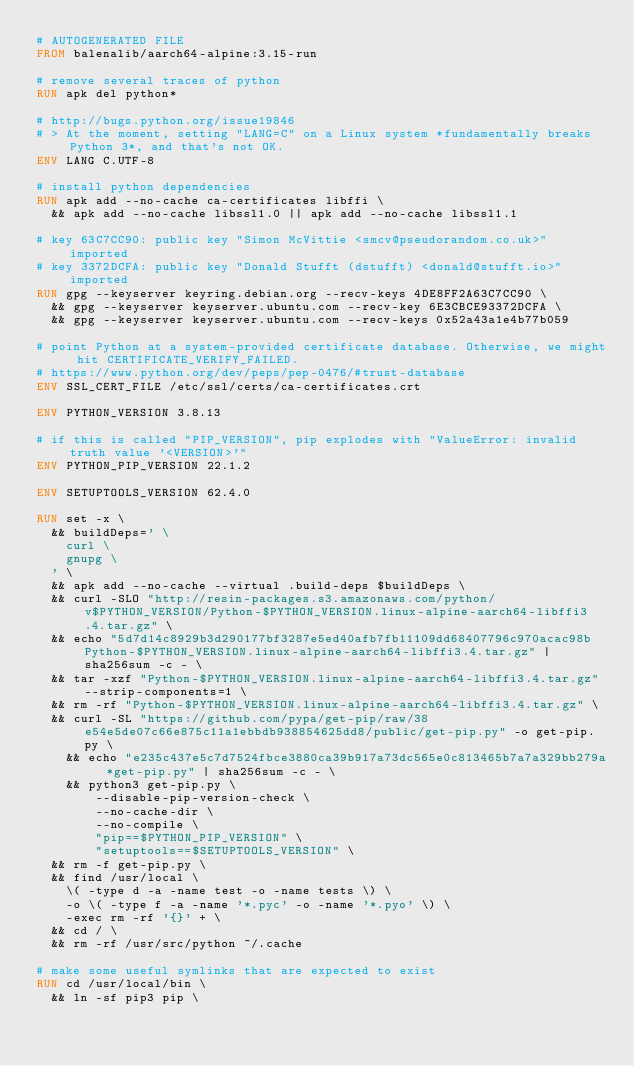<code> <loc_0><loc_0><loc_500><loc_500><_Dockerfile_># AUTOGENERATED FILE
FROM balenalib/aarch64-alpine:3.15-run

# remove several traces of python
RUN apk del python*

# http://bugs.python.org/issue19846
# > At the moment, setting "LANG=C" on a Linux system *fundamentally breaks Python 3*, and that's not OK.
ENV LANG C.UTF-8

# install python dependencies
RUN apk add --no-cache ca-certificates libffi \
	&& apk add --no-cache libssl1.0 || apk add --no-cache libssl1.1

# key 63C7CC90: public key "Simon McVittie <smcv@pseudorandom.co.uk>" imported
# key 3372DCFA: public key "Donald Stufft (dstufft) <donald@stufft.io>" imported
RUN gpg --keyserver keyring.debian.org --recv-keys 4DE8FF2A63C7CC90 \
	&& gpg --keyserver keyserver.ubuntu.com --recv-key 6E3CBCE93372DCFA \
	&& gpg --keyserver keyserver.ubuntu.com --recv-keys 0x52a43a1e4b77b059

# point Python at a system-provided certificate database. Otherwise, we might hit CERTIFICATE_VERIFY_FAILED.
# https://www.python.org/dev/peps/pep-0476/#trust-database
ENV SSL_CERT_FILE /etc/ssl/certs/ca-certificates.crt

ENV PYTHON_VERSION 3.8.13

# if this is called "PIP_VERSION", pip explodes with "ValueError: invalid truth value '<VERSION>'"
ENV PYTHON_PIP_VERSION 22.1.2

ENV SETUPTOOLS_VERSION 62.4.0

RUN set -x \
	&& buildDeps=' \
		curl \
		gnupg \
	' \
	&& apk add --no-cache --virtual .build-deps $buildDeps \
	&& curl -SLO "http://resin-packages.s3.amazonaws.com/python/v$PYTHON_VERSION/Python-$PYTHON_VERSION.linux-alpine-aarch64-libffi3.4.tar.gz" \
	&& echo "5d7d14c8929b3d290177bf3287e5ed40afb7fb11109dd68407796c970acac98b  Python-$PYTHON_VERSION.linux-alpine-aarch64-libffi3.4.tar.gz" | sha256sum -c - \
	&& tar -xzf "Python-$PYTHON_VERSION.linux-alpine-aarch64-libffi3.4.tar.gz" --strip-components=1 \
	&& rm -rf "Python-$PYTHON_VERSION.linux-alpine-aarch64-libffi3.4.tar.gz" \
	&& curl -SL "https://github.com/pypa/get-pip/raw/38e54e5de07c66e875c11a1ebbdb938854625dd8/public/get-pip.py" -o get-pip.py \
    && echo "e235c437e5c7d7524fbce3880ca39b917a73dc565e0c813465b7a7a329bb279a *get-pip.py" | sha256sum -c - \
    && python3 get-pip.py \
        --disable-pip-version-check \
        --no-cache-dir \
        --no-compile \
        "pip==$PYTHON_PIP_VERSION" \
        "setuptools==$SETUPTOOLS_VERSION" \
	&& rm -f get-pip.py \
	&& find /usr/local \
		\( -type d -a -name test -o -name tests \) \
		-o \( -type f -a -name '*.pyc' -o -name '*.pyo' \) \
		-exec rm -rf '{}' + \
	&& cd / \
	&& rm -rf /usr/src/python ~/.cache

# make some useful symlinks that are expected to exist
RUN cd /usr/local/bin \
	&& ln -sf pip3 pip \</code> 